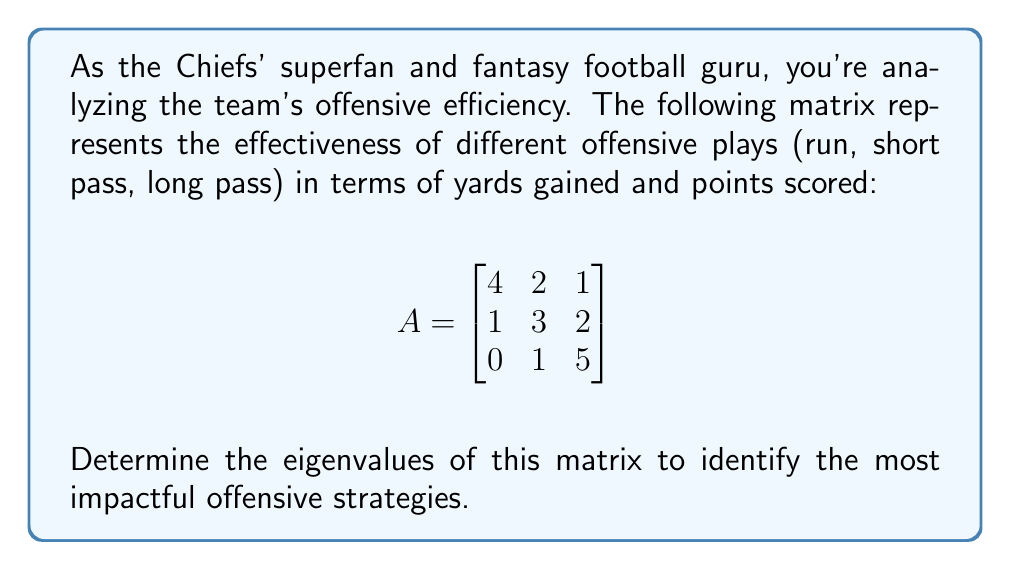Provide a solution to this math problem. To find the eigenvalues of matrix A, we need to solve the characteristic equation:

1) First, we set up the equation: $det(A - \lambda I) = 0$, where $I$ is the 3x3 identity matrix.

2) Expand the determinant:
   $$det\begin{pmatrix}
   4-\lambda & 2 & 1 \\
   1 & 3-\lambda & 2 \\
   0 & 1 & 5-\lambda
   \end{pmatrix} = 0$$

3) Calculate the determinant:
   $(4-\lambda)[(3-\lambda)(5-\lambda) - 2] - 2[1(5-\lambda) - 0] + 1[1 - 0] = 0$

4) Simplify:
   $(4-\lambda)(15-8\lambda+\lambda^2) - 2(5-\lambda) + 1 = 0$
   $60-32\lambda+4\lambda^2-15\lambda+8\lambda^2-\lambda^3 - 10+2\lambda + 1 = 0$

5) Combine like terms:
   $-\lambda^3 + 12\lambda^2 - 45\lambda + 51 = 0$

6) This is a cubic equation. We can factor out $(\lambda - 3)$:
   $-(\lambda - 3)(\lambda^2 - 9\lambda + 17) = 0$

7) Using the quadratic formula for $\lambda^2 - 9\lambda + 17 = 0$:
   $\lambda = \frac{9 \pm \sqrt{81 - 68}}{2} = \frac{9 \pm \sqrt{13}}{2}$

Therefore, the eigenvalues are:
$\lambda_1 = 3$
$\lambda_2 = \frac{9 + \sqrt{13}}{2}$
$\lambda_3 = \frac{9 - \sqrt{13}}{2}$
Answer: $\lambda_1 = 3$, $\lambda_2 = \frac{9 + \sqrt{13}}{2}$, $\lambda_3 = \frac{9 - \sqrt{13}}{2}$ 